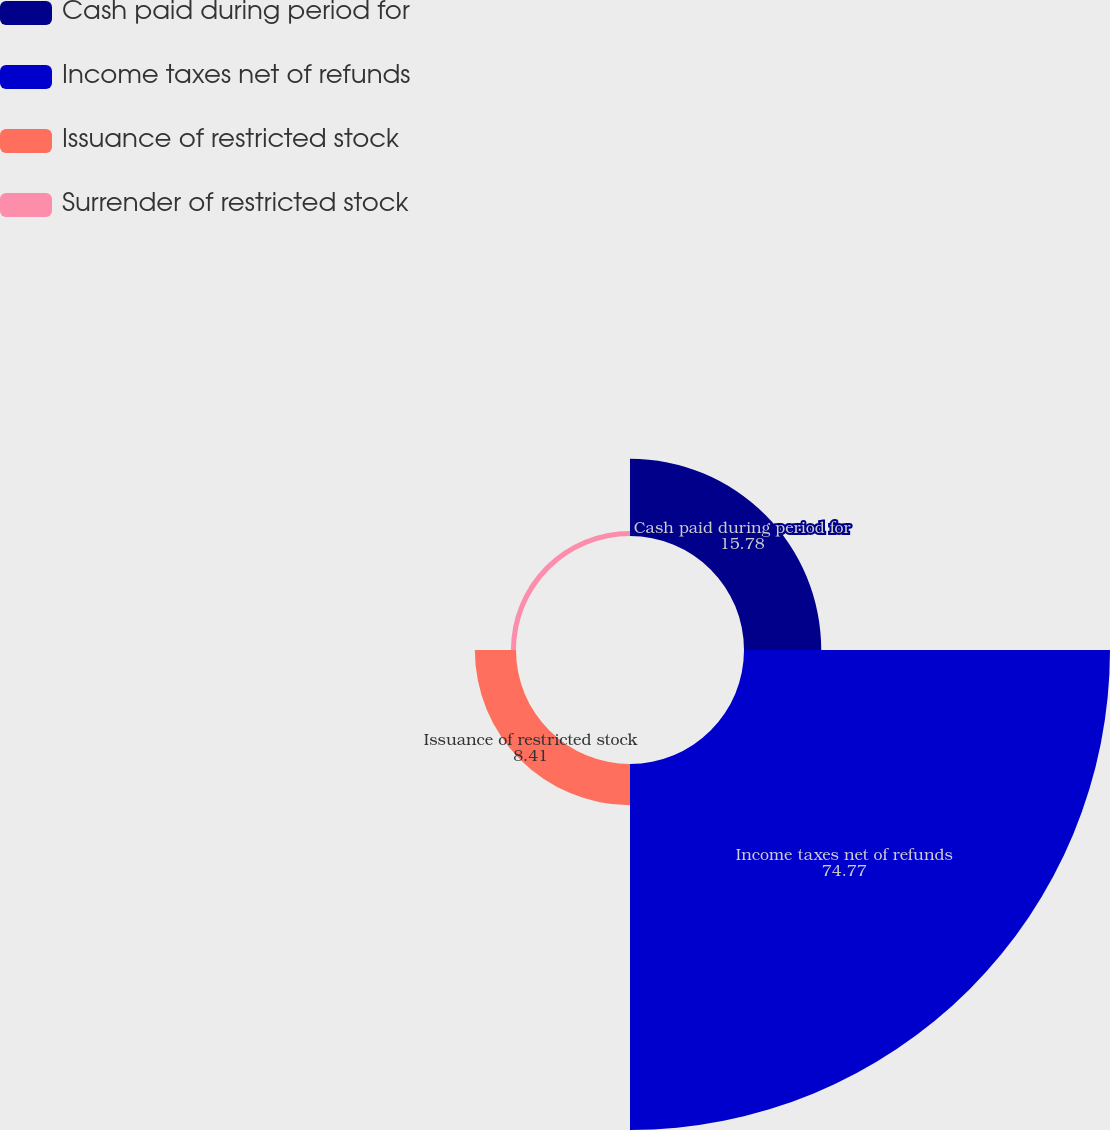<chart> <loc_0><loc_0><loc_500><loc_500><pie_chart><fcel>Cash paid during period for<fcel>Income taxes net of refunds<fcel>Issuance of restricted stock<fcel>Surrender of restricted stock<nl><fcel>15.78%<fcel>74.77%<fcel>8.41%<fcel>1.04%<nl></chart> 